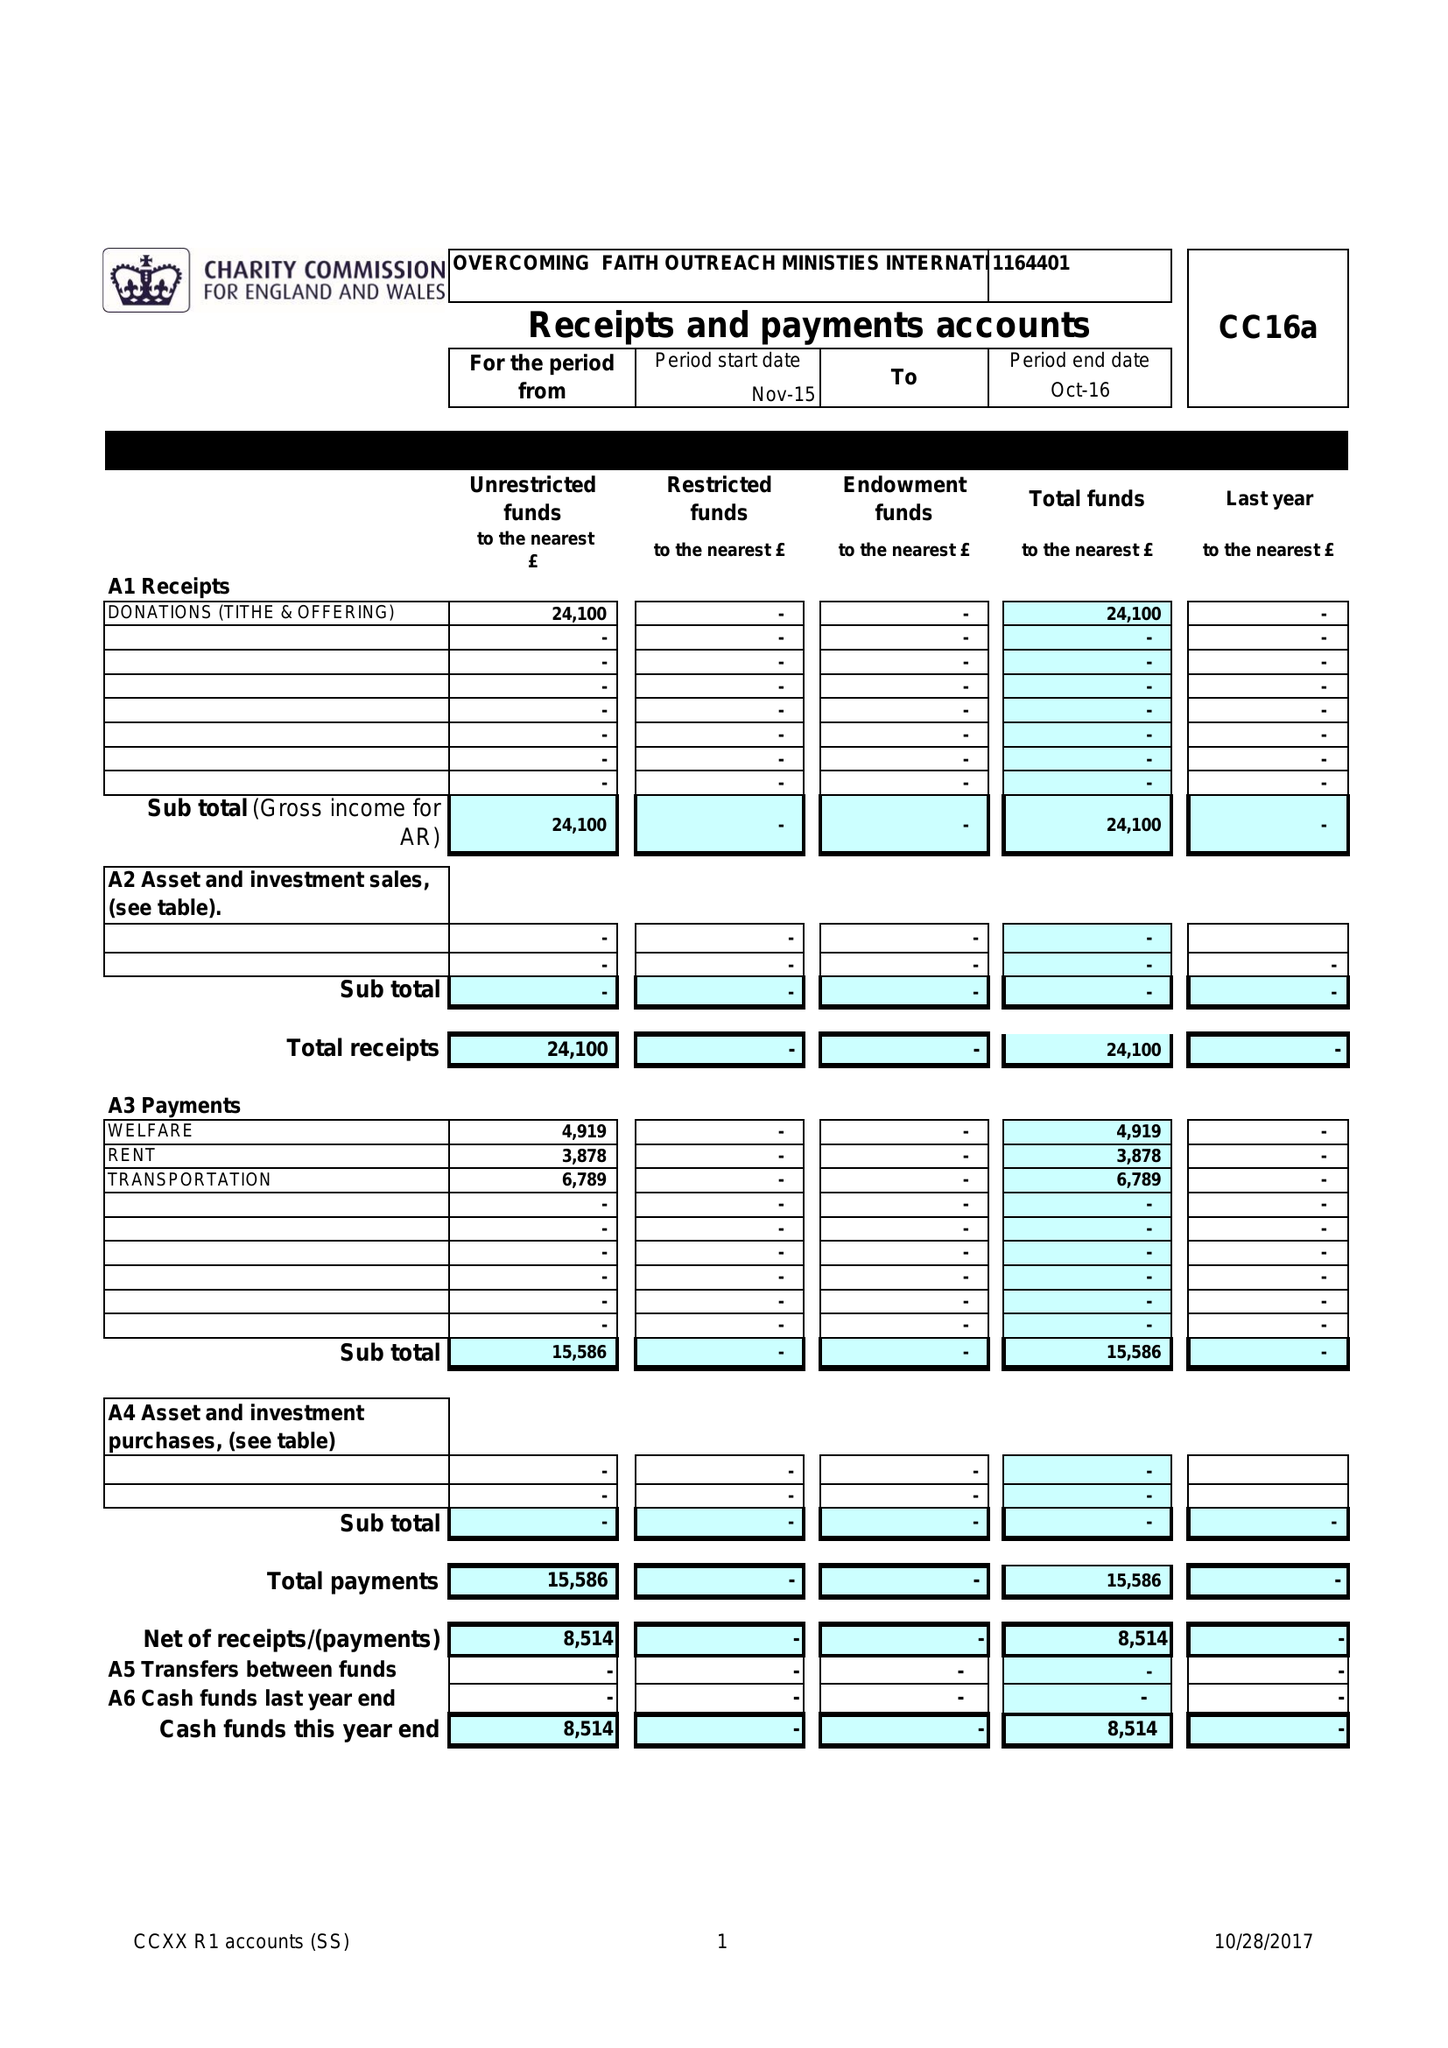What is the value for the income_annually_in_british_pounds?
Answer the question using a single word or phrase. 24100.00 